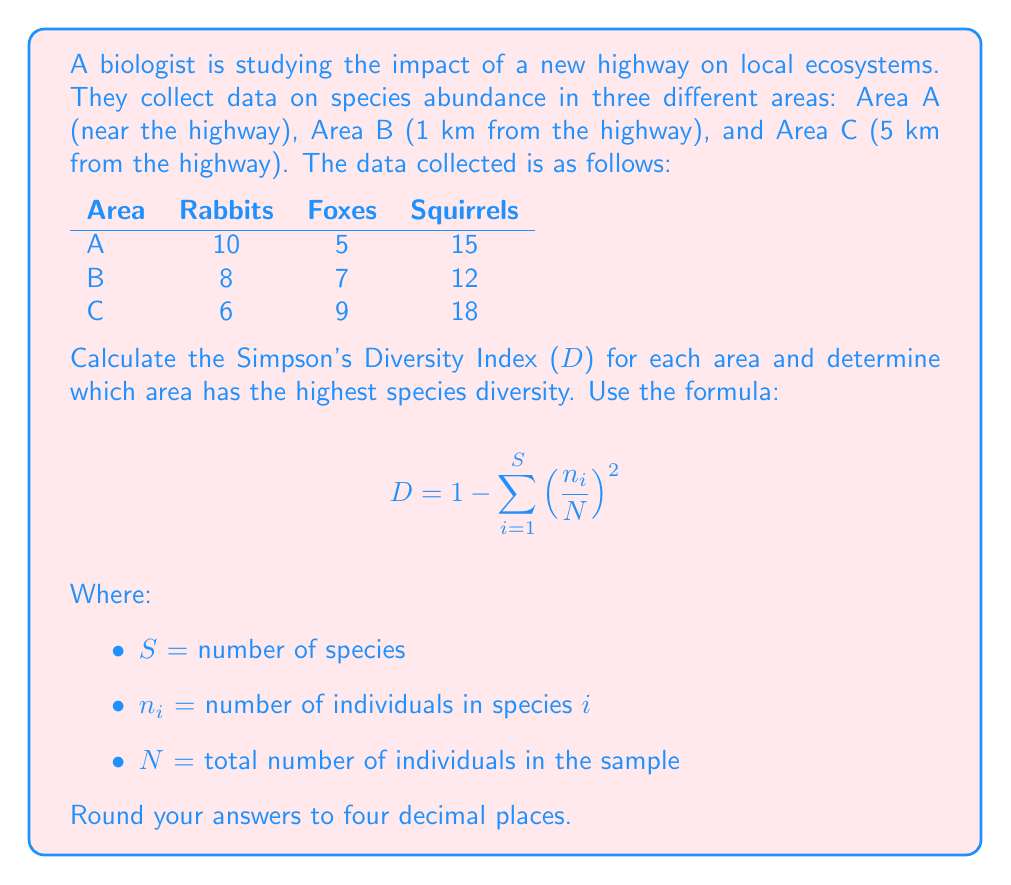Can you solve this math problem? To solve this problem, we need to calculate the Simpson's Diversity Index (D) for each area. Let's go through the process step-by-step:

1. For each area, calculate $N$ (total number of individuals) and $\left(\frac{n_i}{N}\right)^2$ for each species.

2. Sum up $\left(\frac{n_i}{N}\right)^2$ for all species in each area.

3. Subtract the sum from 1 to get D.

Area A:
$N_A = 10 + 5 + 15 = 30$

$\left(\frac{10}{30}\right)^2 = 0.1111$
$\left(\frac{5}{30}\right)^2 = 0.0278$
$\left(\frac{15}{30}\right)^2 = 0.2500$

$\sum \left(\frac{n_i}{N}\right)^2 = 0.1111 + 0.0278 + 0.2500 = 0.3889$

$D_A = 1 - 0.3889 = 0.6111$

Area B:
$N_B = 8 + 7 + 12 = 27$

$\left(\frac{8}{27}\right)^2 = 0.0878$
$\left(\frac{7}{27}\right)^2 = 0.0672$
$\left(\frac{12}{27}\right)^2 = 0.1975$

$\sum \left(\frac{n_i}{N}\right)^2 = 0.0878 + 0.0672 + 0.1975 = 0.3525$

$D_B = 1 - 0.3525 = 0.6475$

Area C:
$N_C = 6 + 9 + 18 = 33$

$\left(\frac{6}{33}\right)^2 = 0.0331$
$\left(\frac{9}{33}\right)^2 = 0.0744$
$\left(\frac{18}{33}\right)^2 = 0.2975$

$\sum \left(\frac{n_i}{N}\right)^2 = 0.0331 + 0.0744 + 0.2975 = 0.4050$

$D_C = 1 - 0.4050 = 0.5950$

Comparing the D values:
$D_A = 0.6111$
$D_B = 0.6475$
$D_C = 0.5950$

Area B has the highest Simpson's Diversity Index, indicating the highest species diversity among the three areas.
Answer: Simpson's Diversity Index for each area:
Area A: 0.6111
Area B: 0.6475
Area C: 0.5950

Area B has the highest species diversity with a Simpson's Diversity Index of 0.6475. 